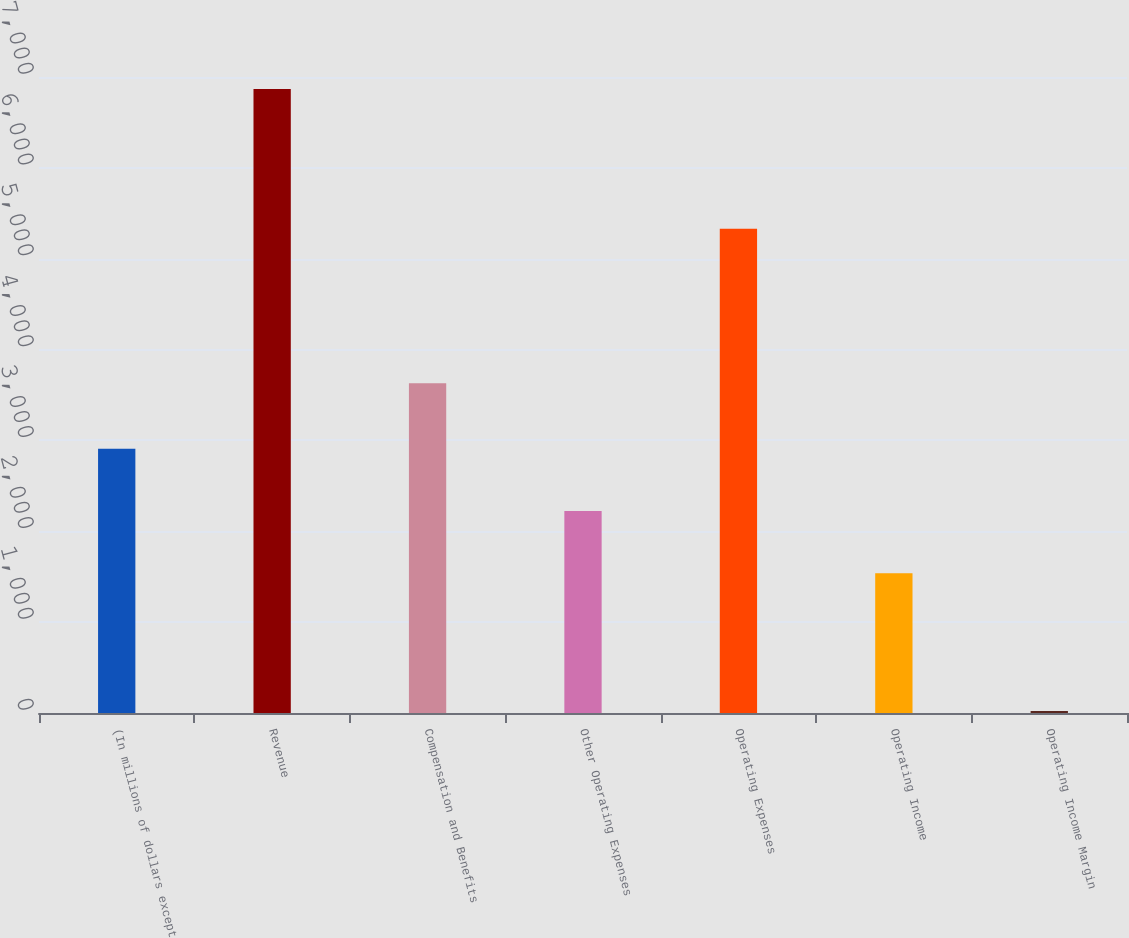Convert chart to OTSL. <chart><loc_0><loc_0><loc_500><loc_500><bar_chart><fcel>(In millions of dollars except<fcel>Revenue<fcel>Compensation and Benefits<fcel>Other Operating Expenses<fcel>Operating Expenses<fcel>Operating Income<fcel>Operating Income Margin<nl><fcel>2908.32<fcel>6869<fcel>3629<fcel>2223.66<fcel>5330<fcel>1539<fcel>22.4<nl></chart> 